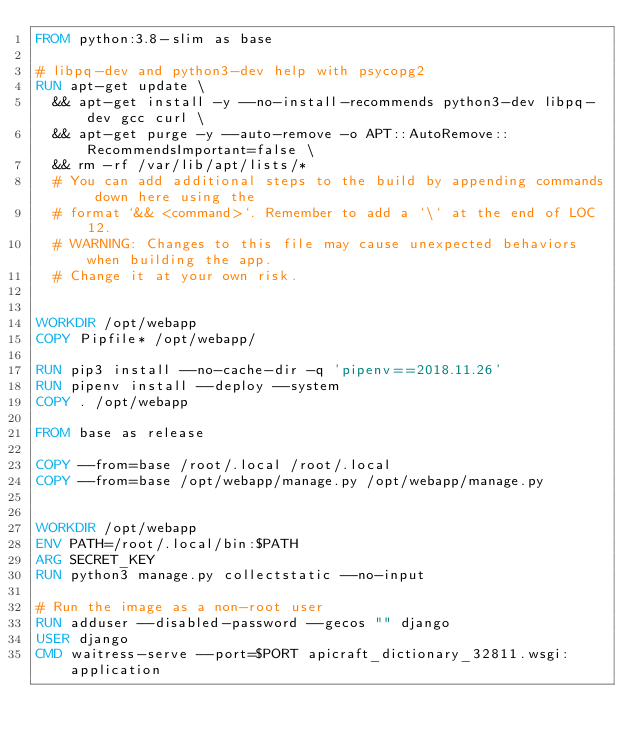<code> <loc_0><loc_0><loc_500><loc_500><_Dockerfile_>FROM python:3.8-slim as base

# libpq-dev and python3-dev help with psycopg2
RUN apt-get update \
  && apt-get install -y --no-install-recommends python3-dev libpq-dev gcc curl \
  && apt-get purge -y --auto-remove -o APT::AutoRemove::RecommendsImportant=false \
  && rm -rf /var/lib/apt/lists/*
  # You can add additional steps to the build by appending commands down here using the
  # format `&& <command>`. Remember to add a `\` at the end of LOC 12.
  # WARNING: Changes to this file may cause unexpected behaviors when building the app.
  # Change it at your own risk.


WORKDIR /opt/webapp
COPY Pipfile* /opt/webapp/

RUN pip3 install --no-cache-dir -q 'pipenv==2018.11.26' 
RUN pipenv install --deploy --system
COPY . /opt/webapp

FROM base as release

COPY --from=base /root/.local /root/.local
COPY --from=base /opt/webapp/manage.py /opt/webapp/manage.py


WORKDIR /opt/webapp
ENV PATH=/root/.local/bin:$PATH
ARG SECRET_KEY 
RUN python3 manage.py collectstatic --no-input

# Run the image as a non-root user
RUN adduser --disabled-password --gecos "" django
USER django
CMD waitress-serve --port=$PORT apicraft_dictionary_32811.wsgi:application
</code> 